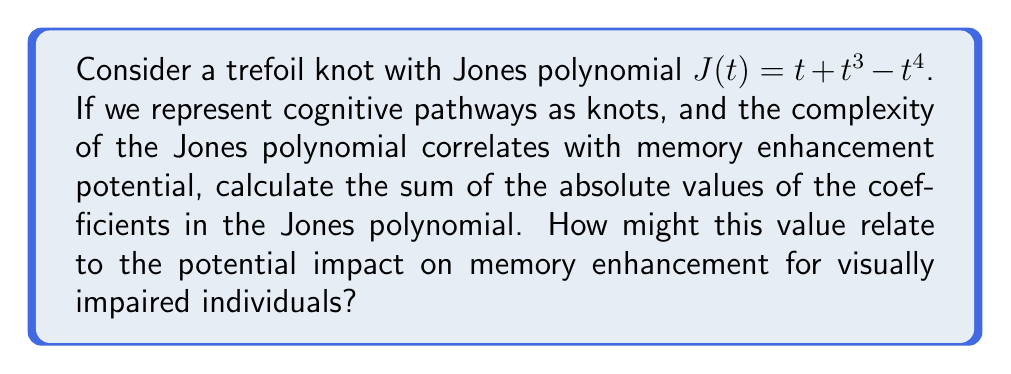Can you answer this question? To solve this problem, we need to follow these steps:

1. Identify the coefficients in the given Jones polynomial:
   $J(t) = t + t^3 - t^4$
   Coefficients are: 1, 1, and -1

2. Calculate the absolute value of each coefficient:
   $|1| = 1$
   $|1| = 1$
   $|-1| = 1$

3. Sum the absolute values:
   $1 + 1 + 1 = 3$

The sum of the absolute values of the coefficients in the Jones polynomial is 3.

Interpretation for cognitive science and memory enhancement:
In the context of cognitive pathways and memory enhancement, this value (3) could be interpreted as a measure of the knot's complexity. A higher sum might indicate more intricate cognitive pathways, potentially correlating with greater memory enhancement opportunities for visually impaired individuals. This quantitative measure could be used to design and evaluate customized reading solutions that aim to strengthen neural connections and improve memory function.
Answer: 3 